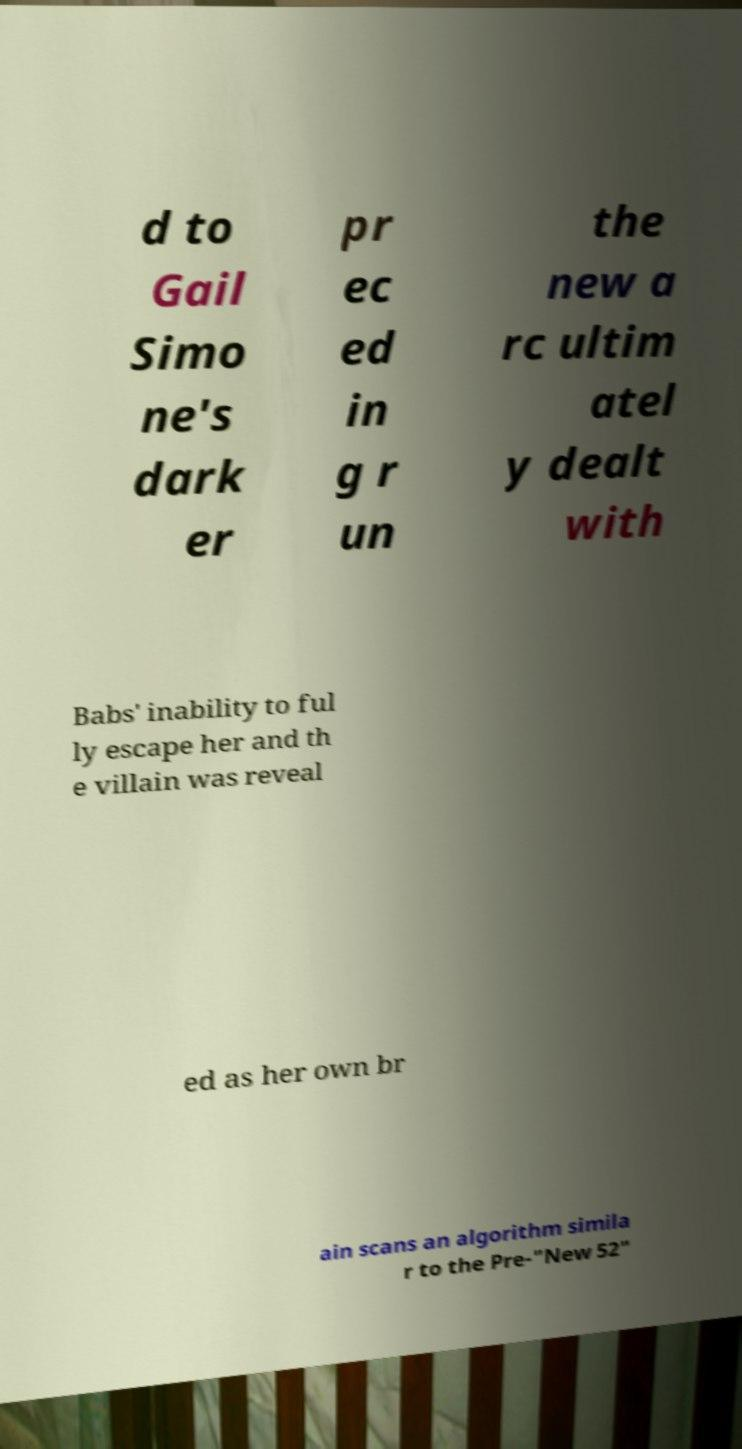There's text embedded in this image that I need extracted. Can you transcribe it verbatim? d to Gail Simo ne's dark er pr ec ed in g r un the new a rc ultim atel y dealt with Babs' inability to ful ly escape her and th e villain was reveal ed as her own br ain scans an algorithm simila r to the Pre-"New 52" 